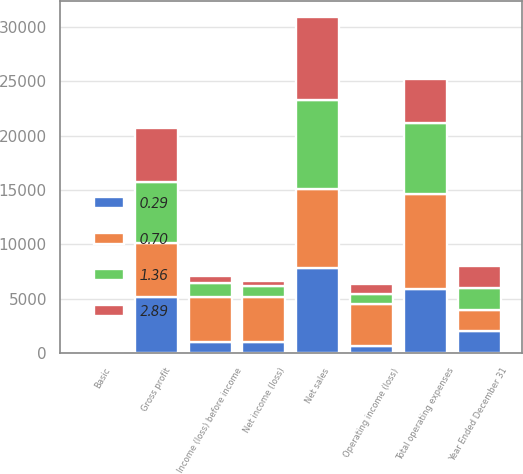Convert chart. <chart><loc_0><loc_0><loc_500><loc_500><stacked_bar_chart><ecel><fcel>Year Ended December 31<fcel>Net sales<fcel>Gross profit<fcel>Total operating expenses<fcel>Operating income (loss)<fcel>Income (loss) before income<fcel>Net income (loss)<fcel>Basic<nl><fcel>0.7<fcel>2012<fcel>7249<fcel>4900<fcel>8768<fcel>3868<fcel>4107<fcel>4068<fcel>2.89<nl><fcel>2.89<fcel>2011<fcel>7622<fcel>4963<fcel>4059<fcel>904<fcel>642<fcel>441<fcel>0.29<nl><fcel>0.29<fcel>2010<fcel>7806<fcel>5207<fcel>5863<fcel>656<fcel>1063<fcel>1065<fcel>0.7<nl><fcel>1.36<fcel>2009<fcel>8188<fcel>5612<fcel>6506<fcel>894<fcel>1308<fcel>1025<fcel>0.68<nl></chart> 